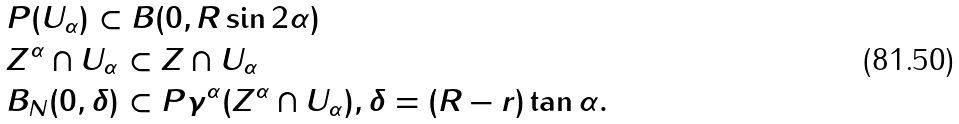Convert formula to latex. <formula><loc_0><loc_0><loc_500><loc_500>& P ( U _ { \alpha } ) \subset B ( 0 , R \sin 2 \alpha ) \\ & Z ^ { \alpha } \cap U _ { \alpha } \subset Z \cap U _ { \alpha } \\ & B _ { N } ( 0 , \delta ) \subset P \gamma ^ { \alpha } ( Z ^ { \alpha } \cap U _ { \alpha } ) , \delta = ( R - r ) \tan \alpha .</formula> 